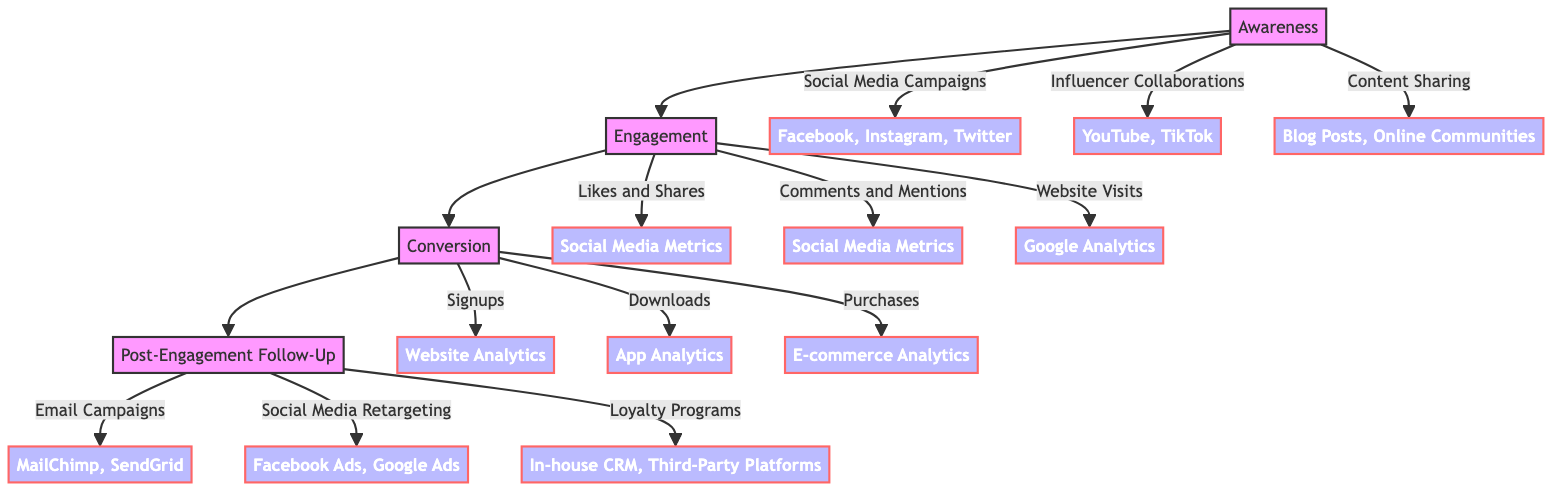What is the first stage of the customer journey? The diagram indicates that the first stage of the customer journey is labeled as "Awareness." This stage focuses on how potential customers become aware of the product or service.
Answer: Awareness How many viral content components are in the Awareness stage? The Awareness stage has three components: "Social Media Campaigns," "Influencer Collaborations," and "Content Sharing." By counting these, we see there are three components in total.
Answer: 3 What type of action is "Likes and Shares"? The "Likes and Shares" action falls under the category of "EngagementAction" as specified in the Engagement stage of the diagram.
Answer: EngagementAction What tools are used for Email Campaigns in the Post-Engagement Follow-Up stage? According to the diagram, the tools used for Email Campaigns are listed as "MailChimp" and "SendGrid." This indicates the specific platforms used for executing these campaigns.
Answer: MailChimp, SendGrid Which stage follows Engagement? The diagram clearly shows that the stage following Engagement is Conversion, making it the next step in the customer journey process.
Answer: Conversion What type of metrics are used for Website Visits? The diagram specifies that "Google Analytics" is the measurement tool used to track Website Visits, indicating the method for monitoring this engagement action.
Answer: Google Analytics How many conversion actions are outlined in the Conversion stage? The Conversion stage lists three distinct actions: "Signups," "Downloads," and "Purchases." Thus, counting these gives us a total of three conversion actions.
Answer: 3 What type of action is "Loyalty Programs"? "Loyalty Programs" is categorized as a "FollowUpAction" in the Post-Engagement Follow-Up stage of the journey, indicating its purpose in maintaining customer relationships after conversion.
Answer: FollowUpAction What are the measurement tools used for Purchases? The diagram states that the measurement tool for Purchases is "E-commerce Analytics," which is specifically designed to analyze purchase behaviors and outcomes.
Answer: E-commerce Analytics 